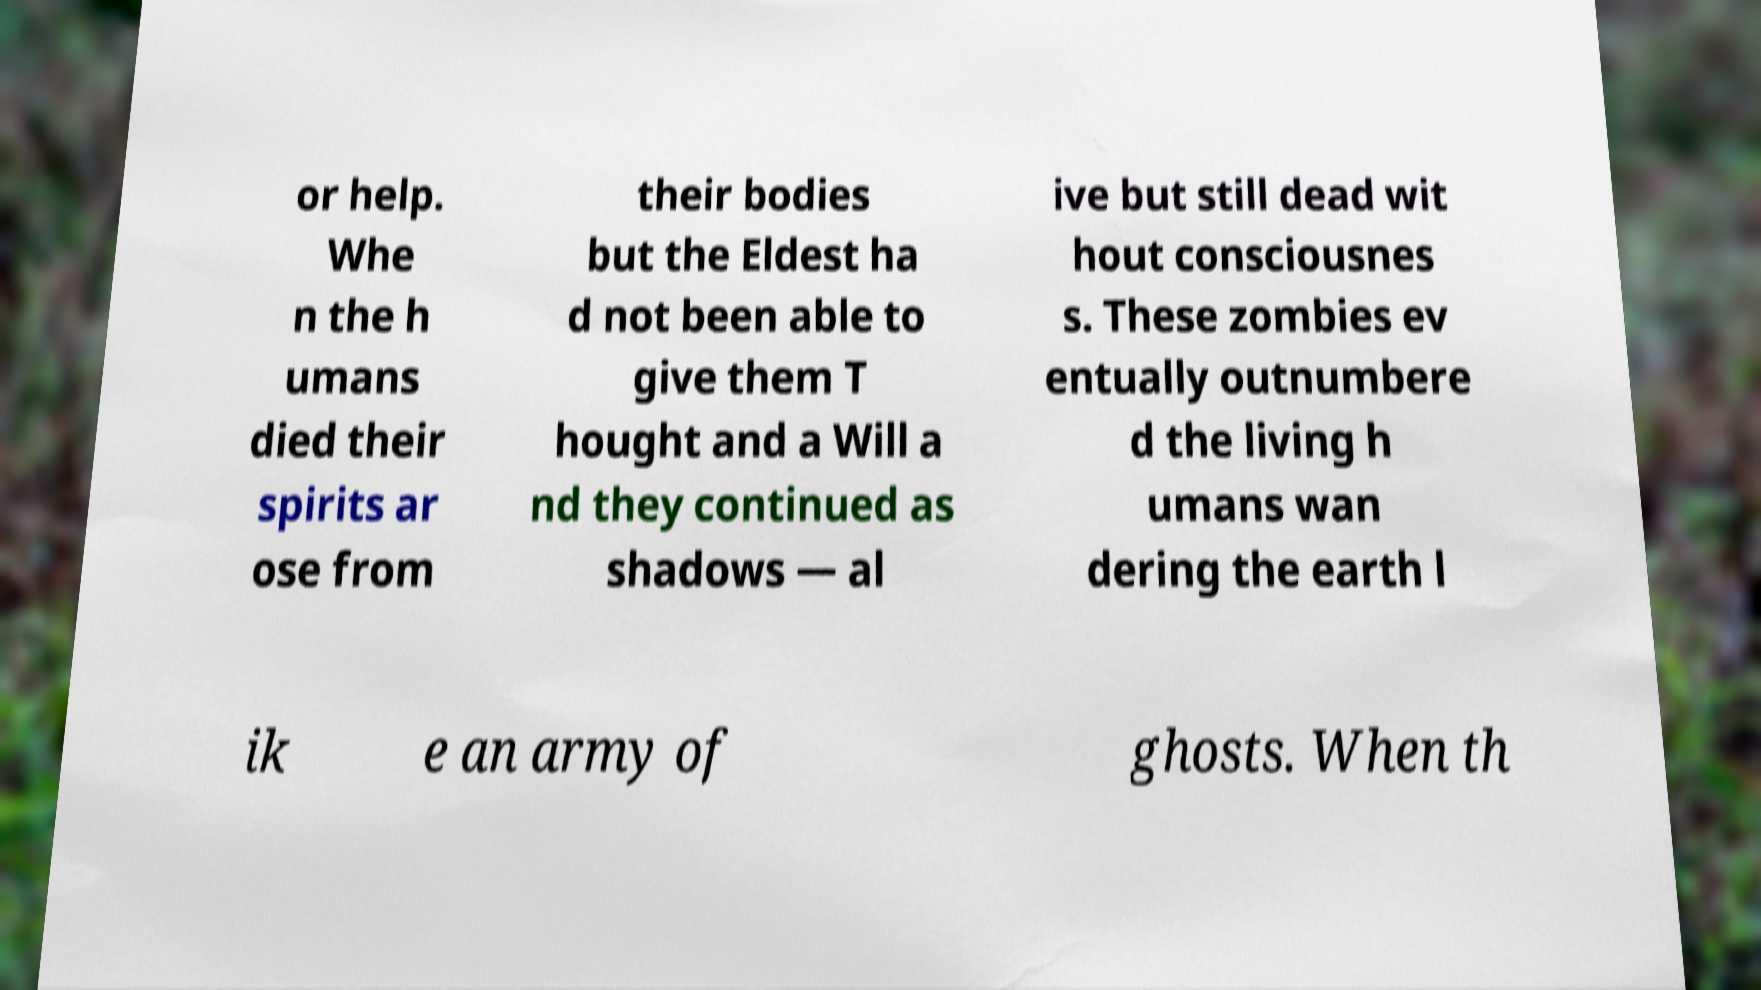There's text embedded in this image that I need extracted. Can you transcribe it verbatim? or help. Whe n the h umans died their spirits ar ose from their bodies but the Eldest ha d not been able to give them T hought and a Will a nd they continued as shadows — al ive but still dead wit hout consciousnes s. These zombies ev entually outnumbere d the living h umans wan dering the earth l ik e an army of ghosts. When th 